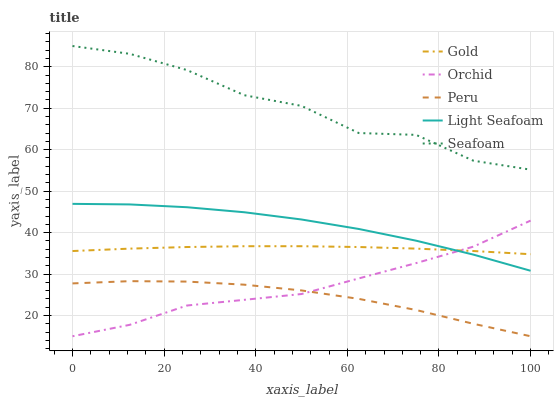Does Peru have the minimum area under the curve?
Answer yes or no. Yes. Does Seafoam have the maximum area under the curve?
Answer yes or no. Yes. Does Seafoam have the minimum area under the curve?
Answer yes or no. No. Does Peru have the maximum area under the curve?
Answer yes or no. No. Is Gold the smoothest?
Answer yes or no. Yes. Is Seafoam the roughest?
Answer yes or no. Yes. Is Peru the smoothest?
Answer yes or no. No. Is Peru the roughest?
Answer yes or no. No. Does Peru have the lowest value?
Answer yes or no. Yes. Does Seafoam have the lowest value?
Answer yes or no. No. Does Seafoam have the highest value?
Answer yes or no. Yes. Does Peru have the highest value?
Answer yes or no. No. Is Orchid less than Seafoam?
Answer yes or no. Yes. Is Seafoam greater than Peru?
Answer yes or no. Yes. Does Orchid intersect Light Seafoam?
Answer yes or no. Yes. Is Orchid less than Light Seafoam?
Answer yes or no. No. Is Orchid greater than Light Seafoam?
Answer yes or no. No. Does Orchid intersect Seafoam?
Answer yes or no. No. 